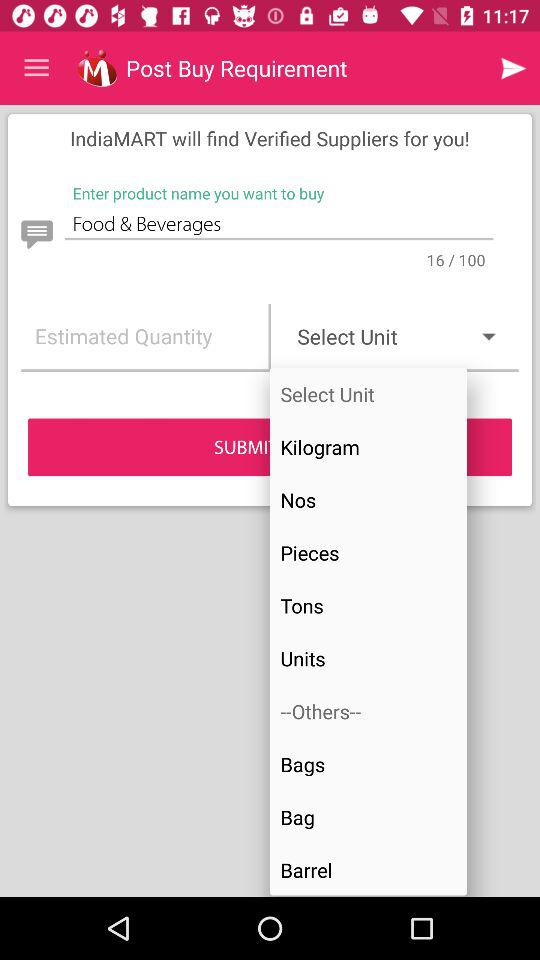Who will find verified suppliers? Verified suppliers will be found using "IndiaMART". 